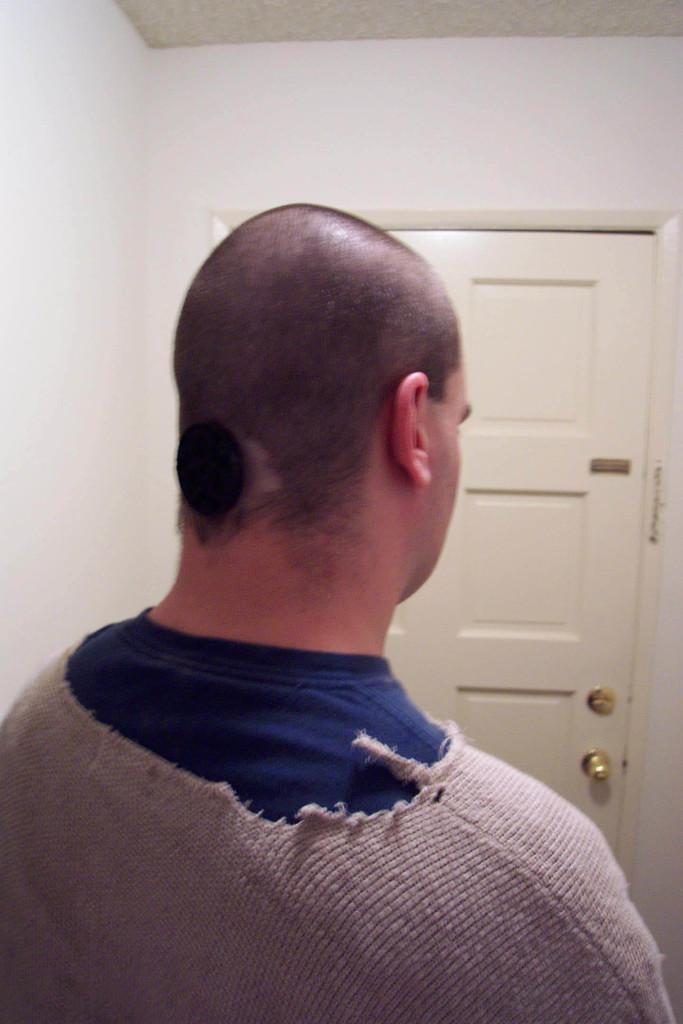Can you describe this image briefly? In this picture we can observe a person wearing blue and grey color T shirt. We can observe a white color door in front of him. There is a wall which is in white color in the background. 